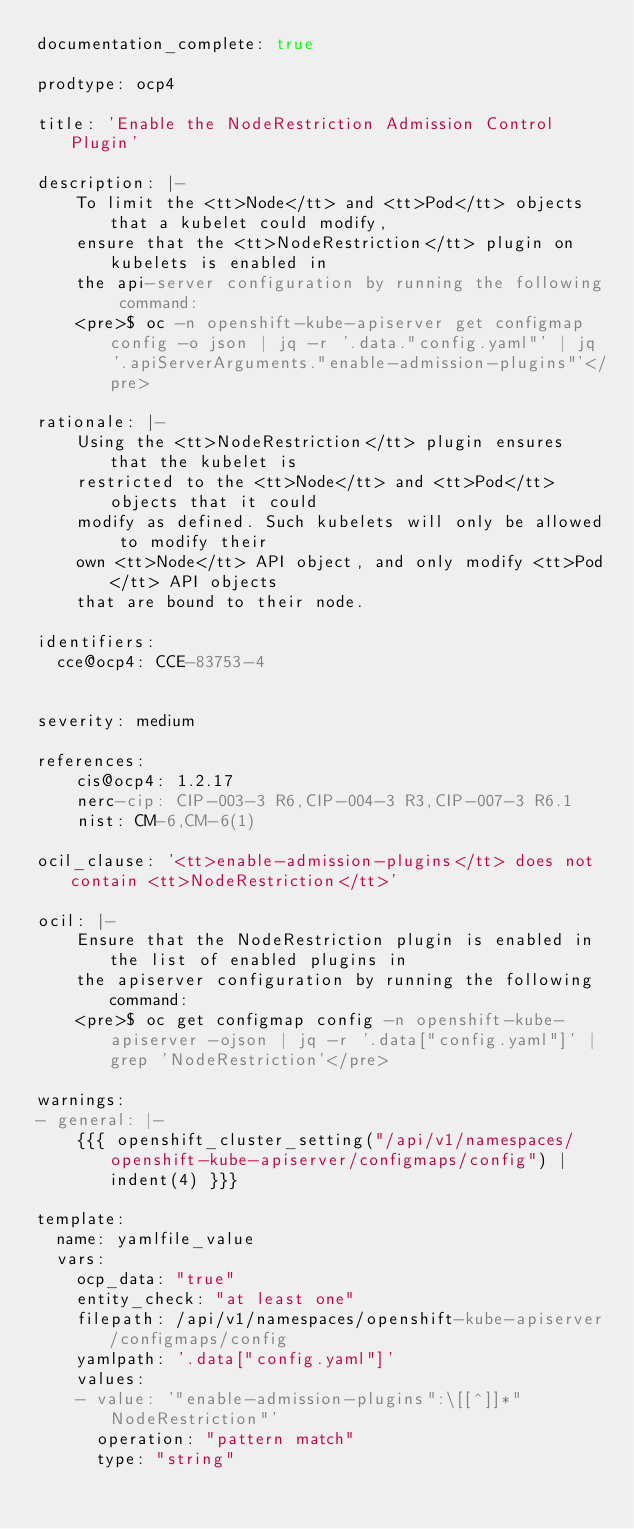Convert code to text. <code><loc_0><loc_0><loc_500><loc_500><_YAML_>documentation_complete: true

prodtype: ocp4

title: 'Enable the NodeRestriction Admission Control Plugin'

description: |-
    To limit the <tt>Node</tt> and <tt>Pod</tt> objects that a kubelet could modify,
    ensure that the <tt>NodeRestriction</tt> plugin on kubelets is enabled in
    the api-server configuration by running the following command:
    <pre>$ oc -n openshift-kube-apiserver get configmap config -o json | jq -r '.data."config.yaml"' | jq '.apiServerArguments."enable-admission-plugins"'</pre>

rationale: |-
    Using the <tt>NodeRestriction</tt> plugin ensures that the kubelet is
    restricted to the <tt>Node</tt> and <tt>Pod</tt> objects that it could
    modify as defined. Such kubelets will only be allowed to modify their
    own <tt>Node</tt> API object, and only modify <tt>Pod</tt> API objects
    that are bound to their node.

identifiers:
  cce@ocp4: CCE-83753-4


severity: medium

references:
    cis@ocp4: 1.2.17
    nerc-cip: CIP-003-3 R6,CIP-004-3 R3,CIP-007-3 R6.1
    nist: CM-6,CM-6(1)

ocil_clause: '<tt>enable-admission-plugins</tt> does not contain <tt>NodeRestriction</tt>'

ocil: |-
    Ensure that the NodeRestriction plugin is enabled in the list of enabled plugins in
    the apiserver configuration by running the following command:
    <pre>$ oc get configmap config -n openshift-kube-apiserver -ojson | jq -r '.data["config.yaml"]' | grep 'NodeRestriction'</pre>

warnings:
- general: |-
    {{{ openshift_cluster_setting("/api/v1/namespaces/openshift-kube-apiserver/configmaps/config") | indent(4) }}}

template:
  name: yamlfile_value
  vars:
    ocp_data: "true"
    entity_check: "at least one"
    filepath: /api/v1/namespaces/openshift-kube-apiserver/configmaps/config
    yamlpath: '.data["config.yaml"]'
    values:
    - value: '"enable-admission-plugins":\[[^]]*"NodeRestriction"'
      operation: "pattern match"
      type: "string"
</code> 